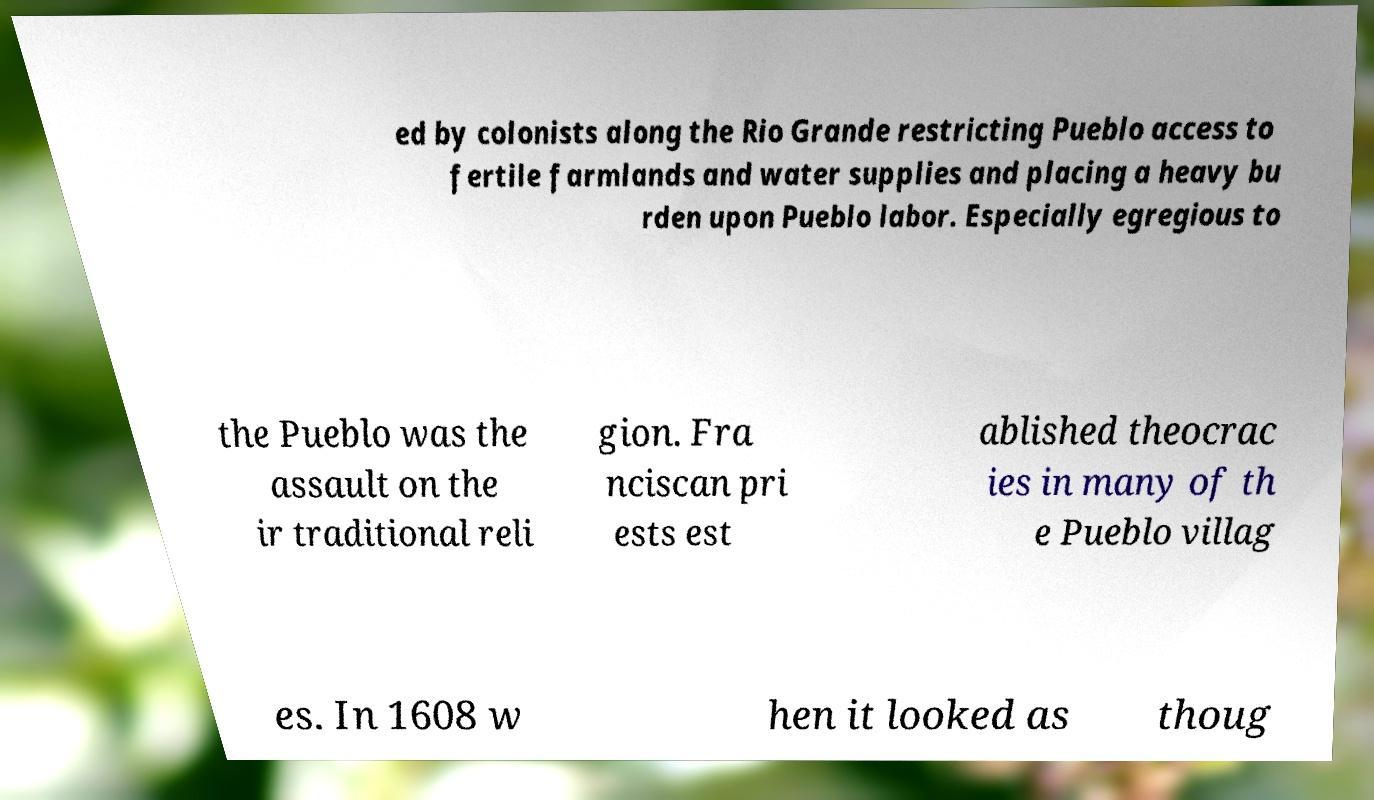Can you accurately transcribe the text from the provided image for me? ed by colonists along the Rio Grande restricting Pueblo access to fertile farmlands and water supplies and placing a heavy bu rden upon Pueblo labor. Especially egregious to the Pueblo was the assault on the ir traditional reli gion. Fra nciscan pri ests est ablished theocrac ies in many of th e Pueblo villag es. In 1608 w hen it looked as thoug 